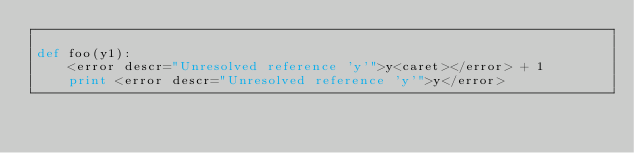<code> <loc_0><loc_0><loc_500><loc_500><_Python_>
def foo(y1):
    <error descr="Unresolved reference 'y'">y<caret></error> + 1
    print <error descr="Unresolved reference 'y'">y</error>

</code> 